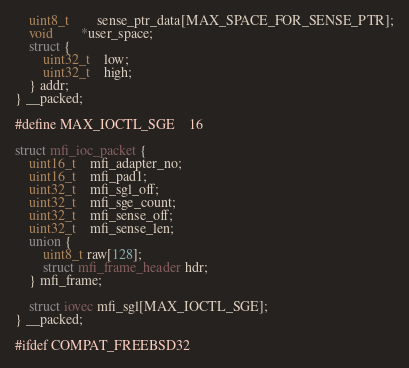<code> <loc_0><loc_0><loc_500><loc_500><_C_>	uint8_t		sense_ptr_data[MAX_SPACE_FOR_SENSE_PTR];
	void 		*user_space;
	struct {
		uint32_t	low;
		uint32_t	high;
	} addr;
} __packed;

#define MAX_IOCTL_SGE	16

struct mfi_ioc_packet {
	uint16_t	mfi_adapter_no;
	uint16_t	mfi_pad1;
	uint32_t	mfi_sgl_off;
	uint32_t	mfi_sge_count;
	uint32_t	mfi_sense_off;
	uint32_t	mfi_sense_len;
	union {
		uint8_t raw[128];
		struct mfi_frame_header hdr;
	} mfi_frame;

	struct iovec mfi_sgl[MAX_IOCTL_SGE];
} __packed;

#ifdef COMPAT_FREEBSD32</code> 